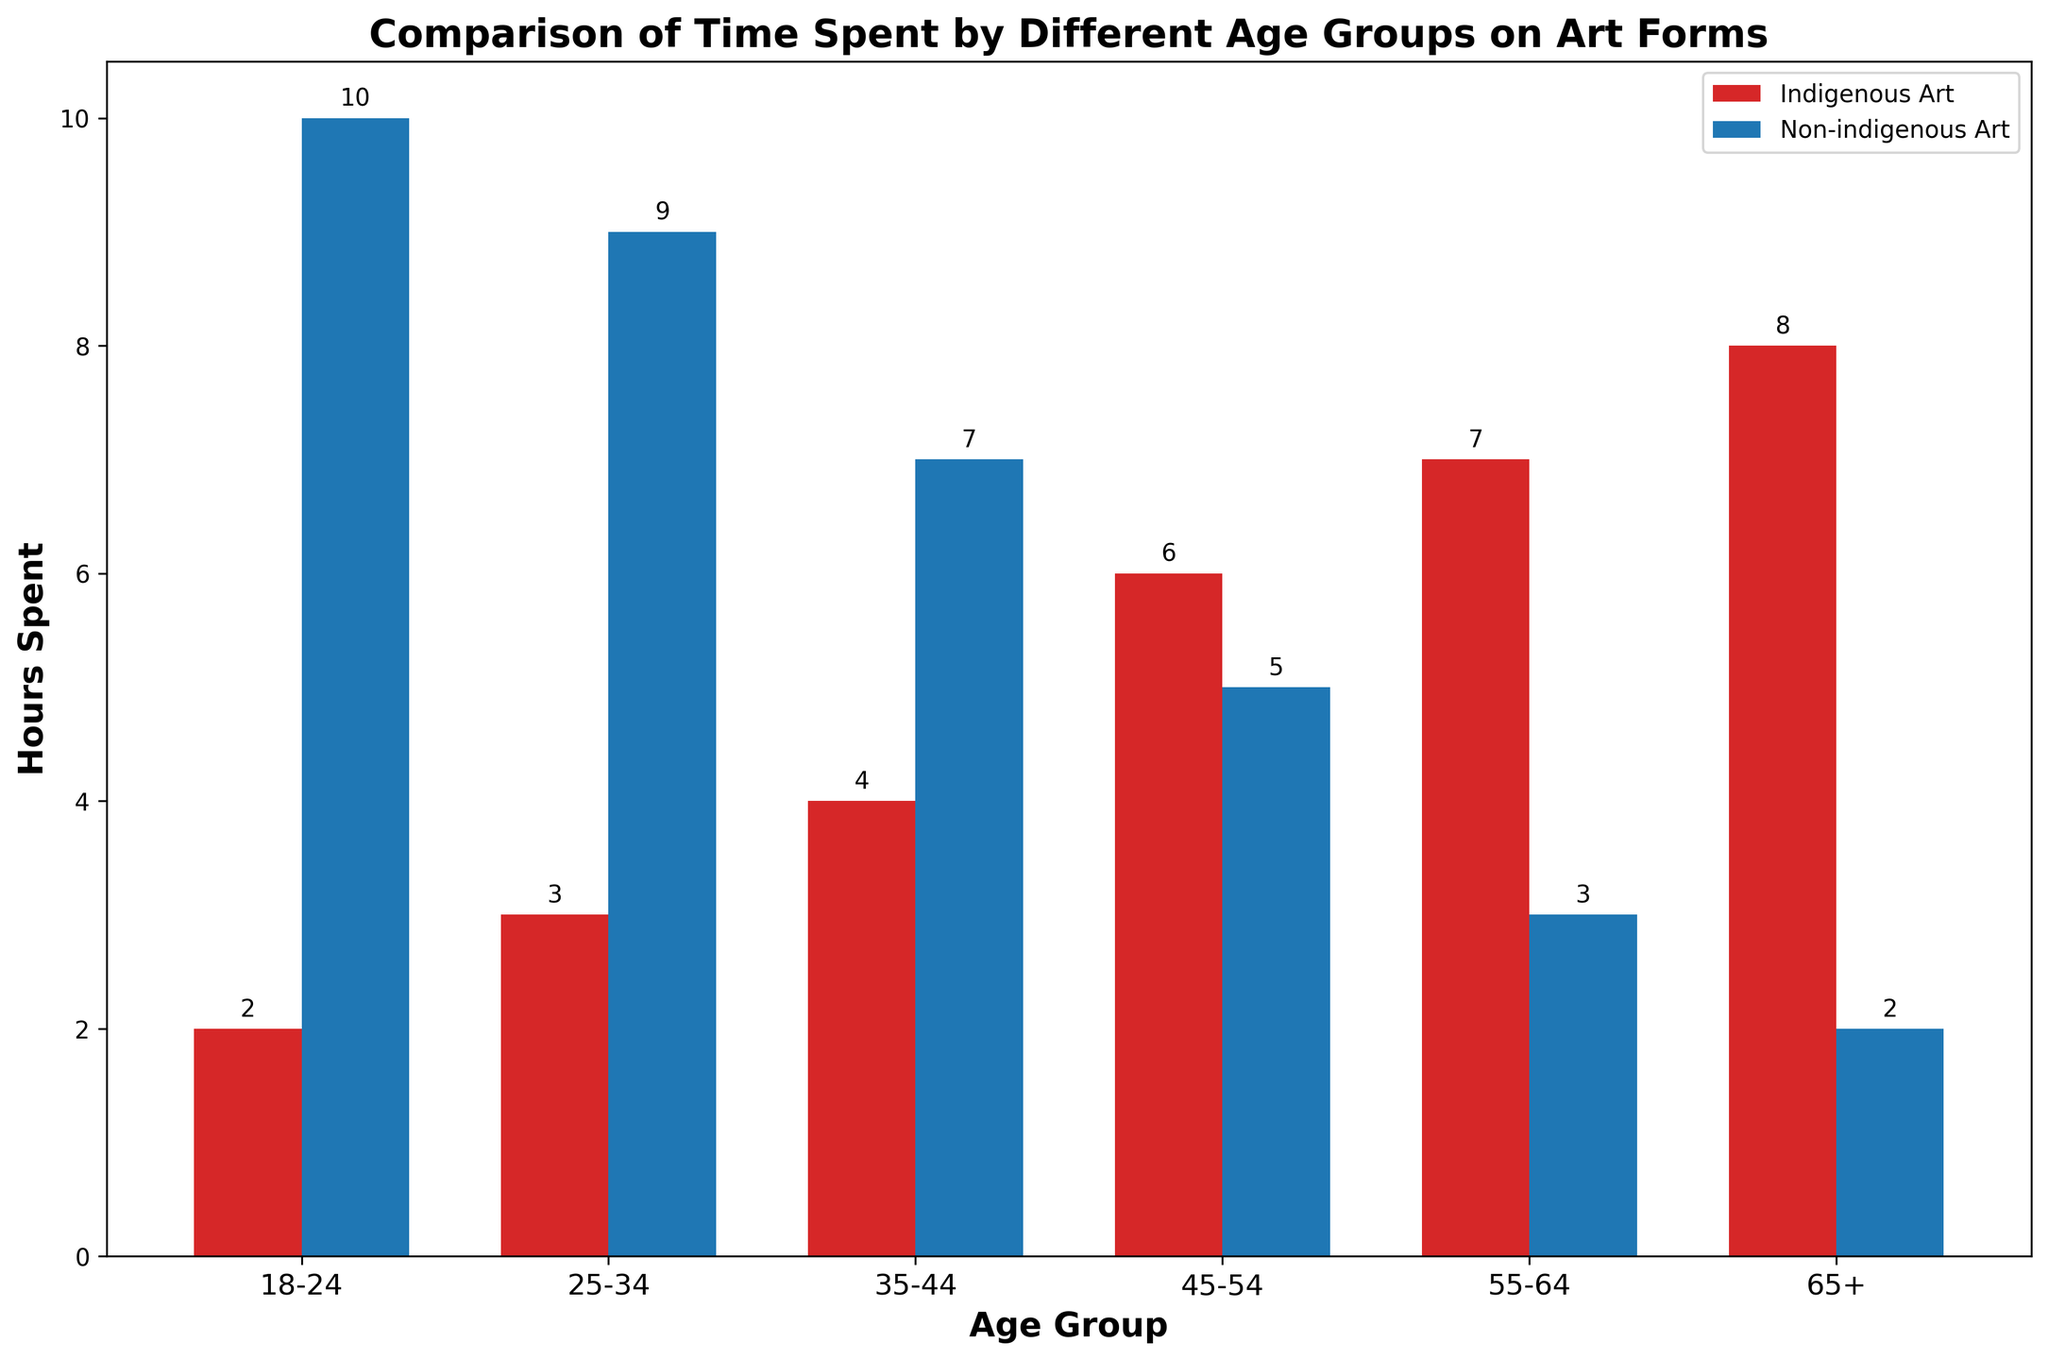Which age group spends the most time on indigenous art? The highest bar in the Indigenous Art category is for the 65+ age group.
Answer: 65+ Which age group spends the least time on non-indigenous art? The lowest bar in the Non-indigenous Art category is for the 65+ age group.
Answer: 65+ By how many hours does the 45-54 age group's time spent on indigenous art exceed that on non-indigenous art? In the 45-54 age group, time spent on Indigenous Art is 6 hours while on Non-indigenous Art it is 5 hours. Subtract the two values: 6 - 5.
Answer: 1 hour Which three age groups have the highest total hours spent on both indigenous and non-indigenous art forms? Calculate the total hours for each age group and compare:  
- 18-24: 2 + 10 = 12  
- 25-34: 3 + 9 = 12  
- 35-44: 4 + 7 = 11  
- 45-54: 6 + 5 = 11  
- 55-64: 7 + 3 = 10  
- 65+: 8 + 2 = 10  
The age groups 18-24, 25-34, and 35-44 have the highest totals.
Answer: 18-24, 25-34, 35-44 What is the average time spent on indigenous art across all age groups? Sum the time spent on Indigenous Art for all age groups then divide by the number of age groups: (2 + 3 + 4 + 6 + 7 + 8) / 6 = 30 / 6 = 5.
Answer: 5 hours For the 25-34 age group, by how many hours does the time spent on non-indigenous art exceed that on indigenous art? In the 25-34 age group, compare the bars: 9 hours for Non-indigenous Art and 3 hours for Indigenous Art. Subtract the two values: 9 - 3.
Answer: 6 hours 